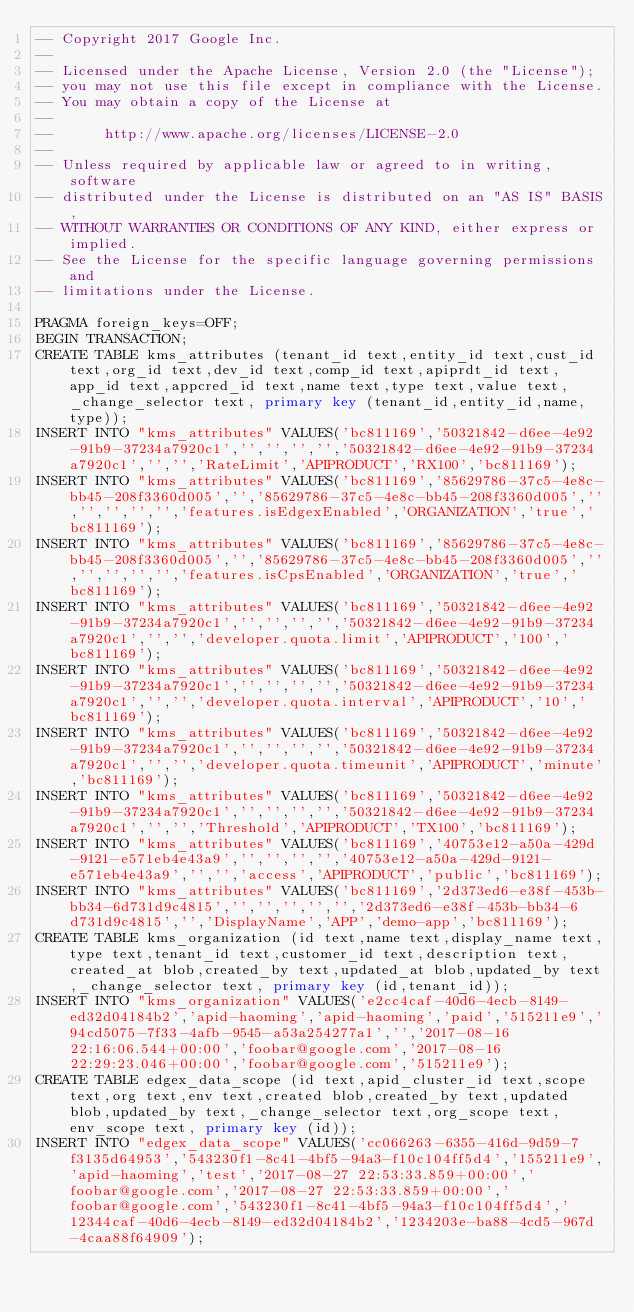<code> <loc_0><loc_0><loc_500><loc_500><_SQL_>-- Copyright 2017 Google Inc.
--
-- Licensed under the Apache License, Version 2.0 (the "License");
-- you may not use this file except in compliance with the License.
-- You may obtain a copy of the License at
--
--      http://www.apache.org/licenses/LICENSE-2.0
--
-- Unless required by applicable law or agreed to in writing, software
-- distributed under the License is distributed on an "AS IS" BASIS,
-- WITHOUT WARRANTIES OR CONDITIONS OF ANY KIND, either express or implied.
-- See the License for the specific language governing permissions and
-- limitations under the License.

PRAGMA foreign_keys=OFF;
BEGIN TRANSACTION;
CREATE TABLE kms_attributes (tenant_id text,entity_id text,cust_id text,org_id text,dev_id text,comp_id text,apiprdt_id text,app_id text,appcred_id text,name text,type text,value text,_change_selector text, primary key (tenant_id,entity_id,name,type));
INSERT INTO "kms_attributes" VALUES('bc811169','50321842-d6ee-4e92-91b9-37234a7920c1','','','','','50321842-d6ee-4e92-91b9-37234a7920c1','','','RateLimit','APIPRODUCT','RX100','bc811169');
INSERT INTO "kms_attributes" VALUES('bc811169','85629786-37c5-4e8c-bb45-208f3360d005','','85629786-37c5-4e8c-bb45-208f3360d005','','','','','','features.isEdgexEnabled','ORGANIZATION','true','bc811169');
INSERT INTO "kms_attributes" VALUES('bc811169','85629786-37c5-4e8c-bb45-208f3360d005','','85629786-37c5-4e8c-bb45-208f3360d005','','','','','','features.isCpsEnabled','ORGANIZATION','true','bc811169');
INSERT INTO "kms_attributes" VALUES('bc811169','50321842-d6ee-4e92-91b9-37234a7920c1','','','','','50321842-d6ee-4e92-91b9-37234a7920c1','','','developer.quota.limit','APIPRODUCT','100','bc811169');
INSERT INTO "kms_attributes" VALUES('bc811169','50321842-d6ee-4e92-91b9-37234a7920c1','','','','','50321842-d6ee-4e92-91b9-37234a7920c1','','','developer.quota.interval','APIPRODUCT','10','bc811169');
INSERT INTO "kms_attributes" VALUES('bc811169','50321842-d6ee-4e92-91b9-37234a7920c1','','','','','50321842-d6ee-4e92-91b9-37234a7920c1','','','developer.quota.timeunit','APIPRODUCT','minute','bc811169');
INSERT INTO "kms_attributes" VALUES('bc811169','50321842-d6ee-4e92-91b9-37234a7920c1','','','','','50321842-d6ee-4e92-91b9-37234a7920c1','','','Threshold','APIPRODUCT','TX100','bc811169');
INSERT INTO "kms_attributes" VALUES('bc811169','40753e12-a50a-429d-9121-e571eb4e43a9','','','','','40753e12-a50a-429d-9121-e571eb4e43a9','','','access','APIPRODUCT','public','bc811169');
INSERT INTO "kms_attributes" VALUES('bc811169','2d373ed6-e38f-453b-bb34-6d731d9c4815','','','','','','2d373ed6-e38f-453b-bb34-6d731d9c4815','','DisplayName','APP','demo-app','bc811169');
CREATE TABLE kms_organization (id text,name text,display_name text,type text,tenant_id text,customer_id text,description text,created_at blob,created_by text,updated_at blob,updated_by text,_change_selector text, primary key (id,tenant_id));
INSERT INTO "kms_organization" VALUES('e2cc4caf-40d6-4ecb-8149-ed32d04184b2','apid-haoming','apid-haoming','paid','515211e9','94cd5075-7f33-4afb-9545-a53a254277a1','','2017-08-16 22:16:06.544+00:00','foobar@google.com','2017-08-16 22:29:23.046+00:00','foobar@google.com','515211e9');
CREATE TABLE edgex_data_scope (id text,apid_cluster_id text,scope text,org text,env text,created blob,created_by text,updated blob,updated_by text,_change_selector text,org_scope text,env_scope text, primary key (id));
INSERT INTO "edgex_data_scope" VALUES('cc066263-6355-416d-9d59-7f3135d64953','543230f1-8c41-4bf5-94a3-f10c104ff5d4','155211e9','apid-haoming','test','2017-08-27 22:53:33.859+00:00','foobar@google.com','2017-08-27 22:53:33.859+00:00','foobar@google.com','543230f1-8c41-4bf5-94a3-f10c104ff5d4','12344caf-40d6-4ecb-8149-ed32d04184b2','1234203e-ba88-4cd5-967d-4caa88f64909');</code> 